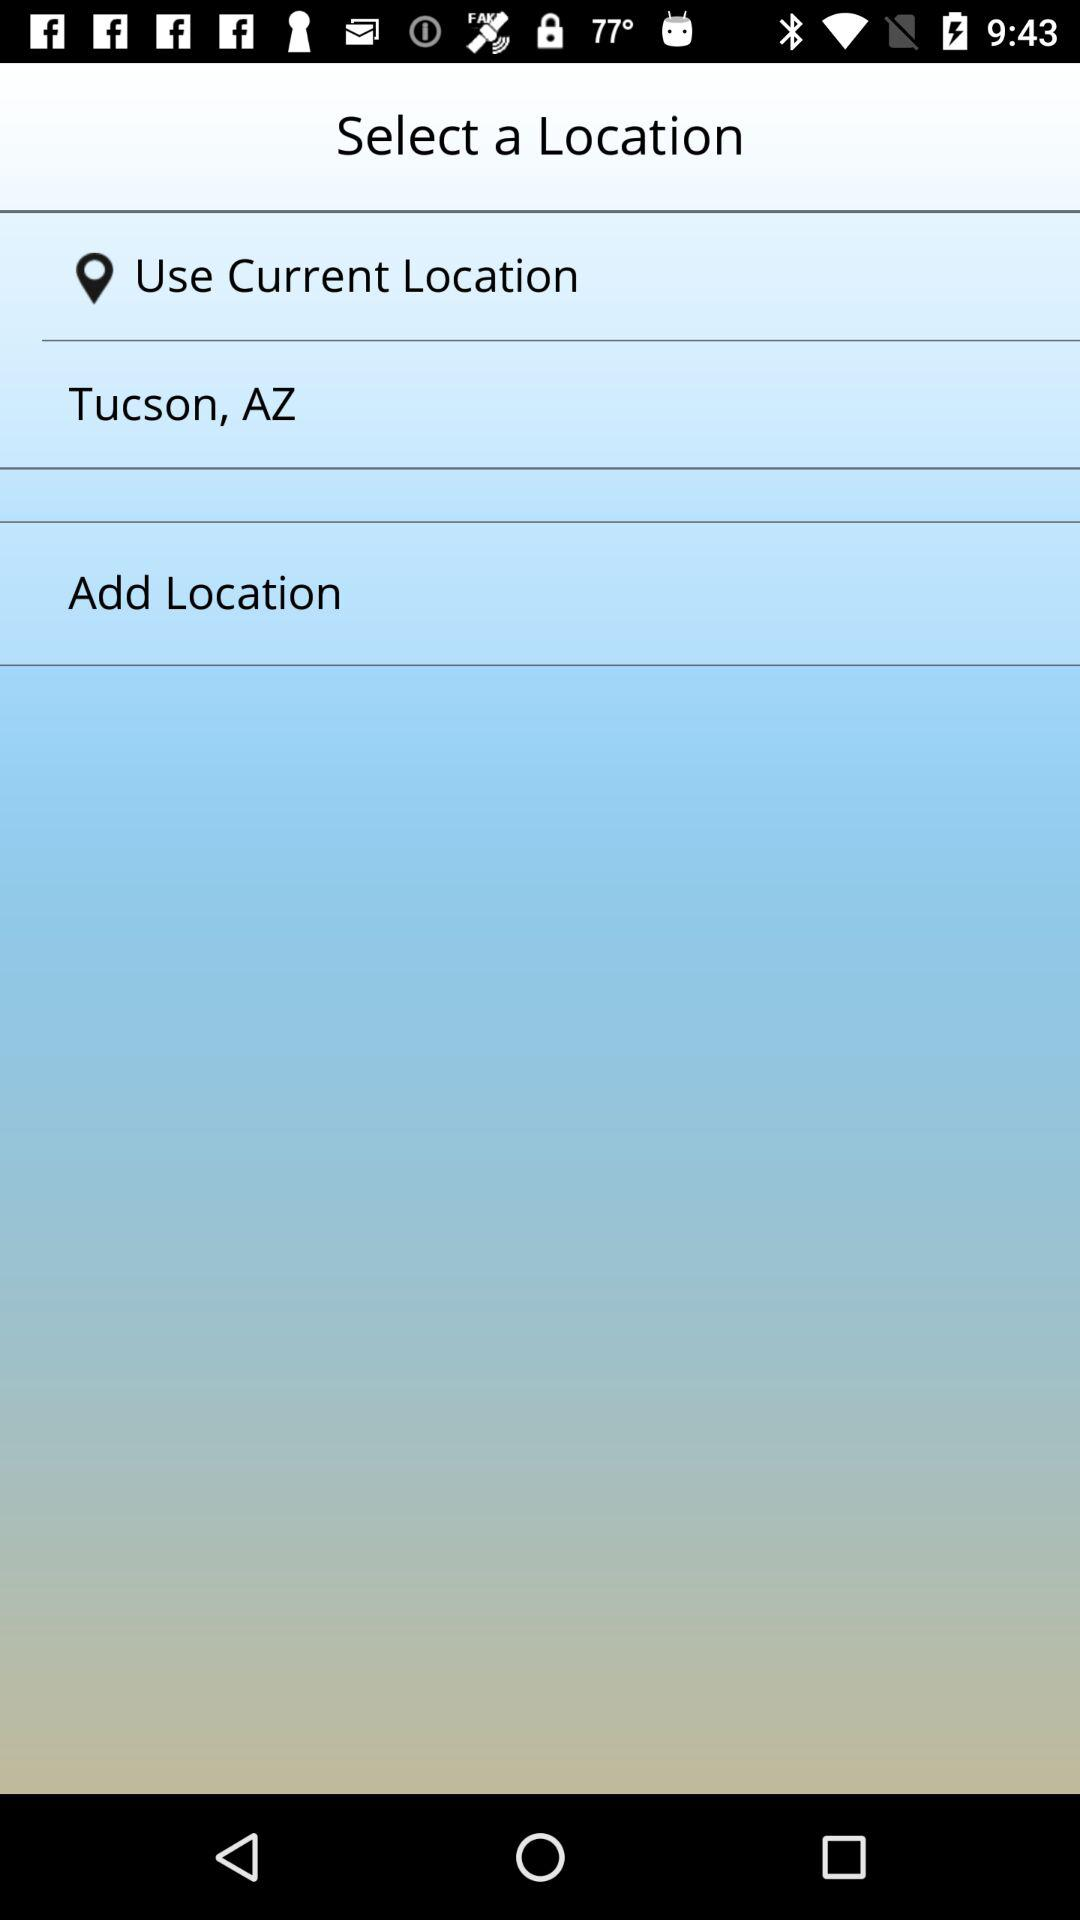What is the mentioned location? The mentioned location is Tucson, AZ. 